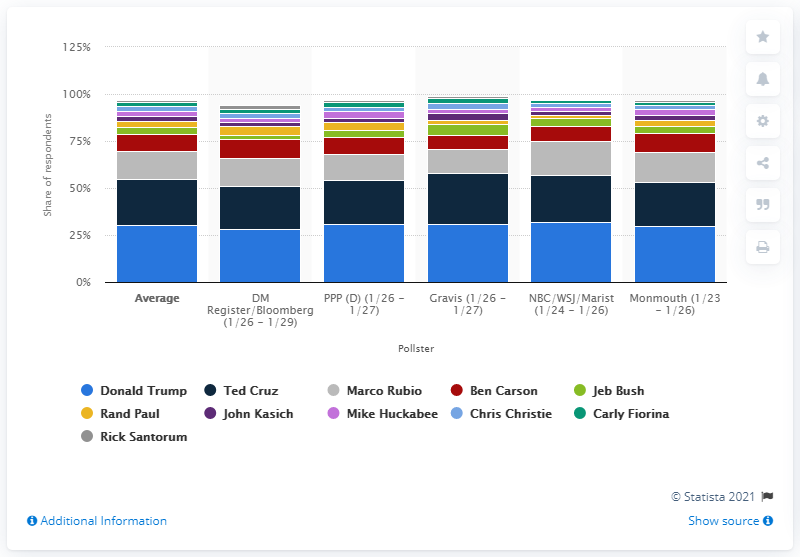Give some essential details in this illustration. The second most popular candidate in the Iowa caucus was Ted Cruz. 